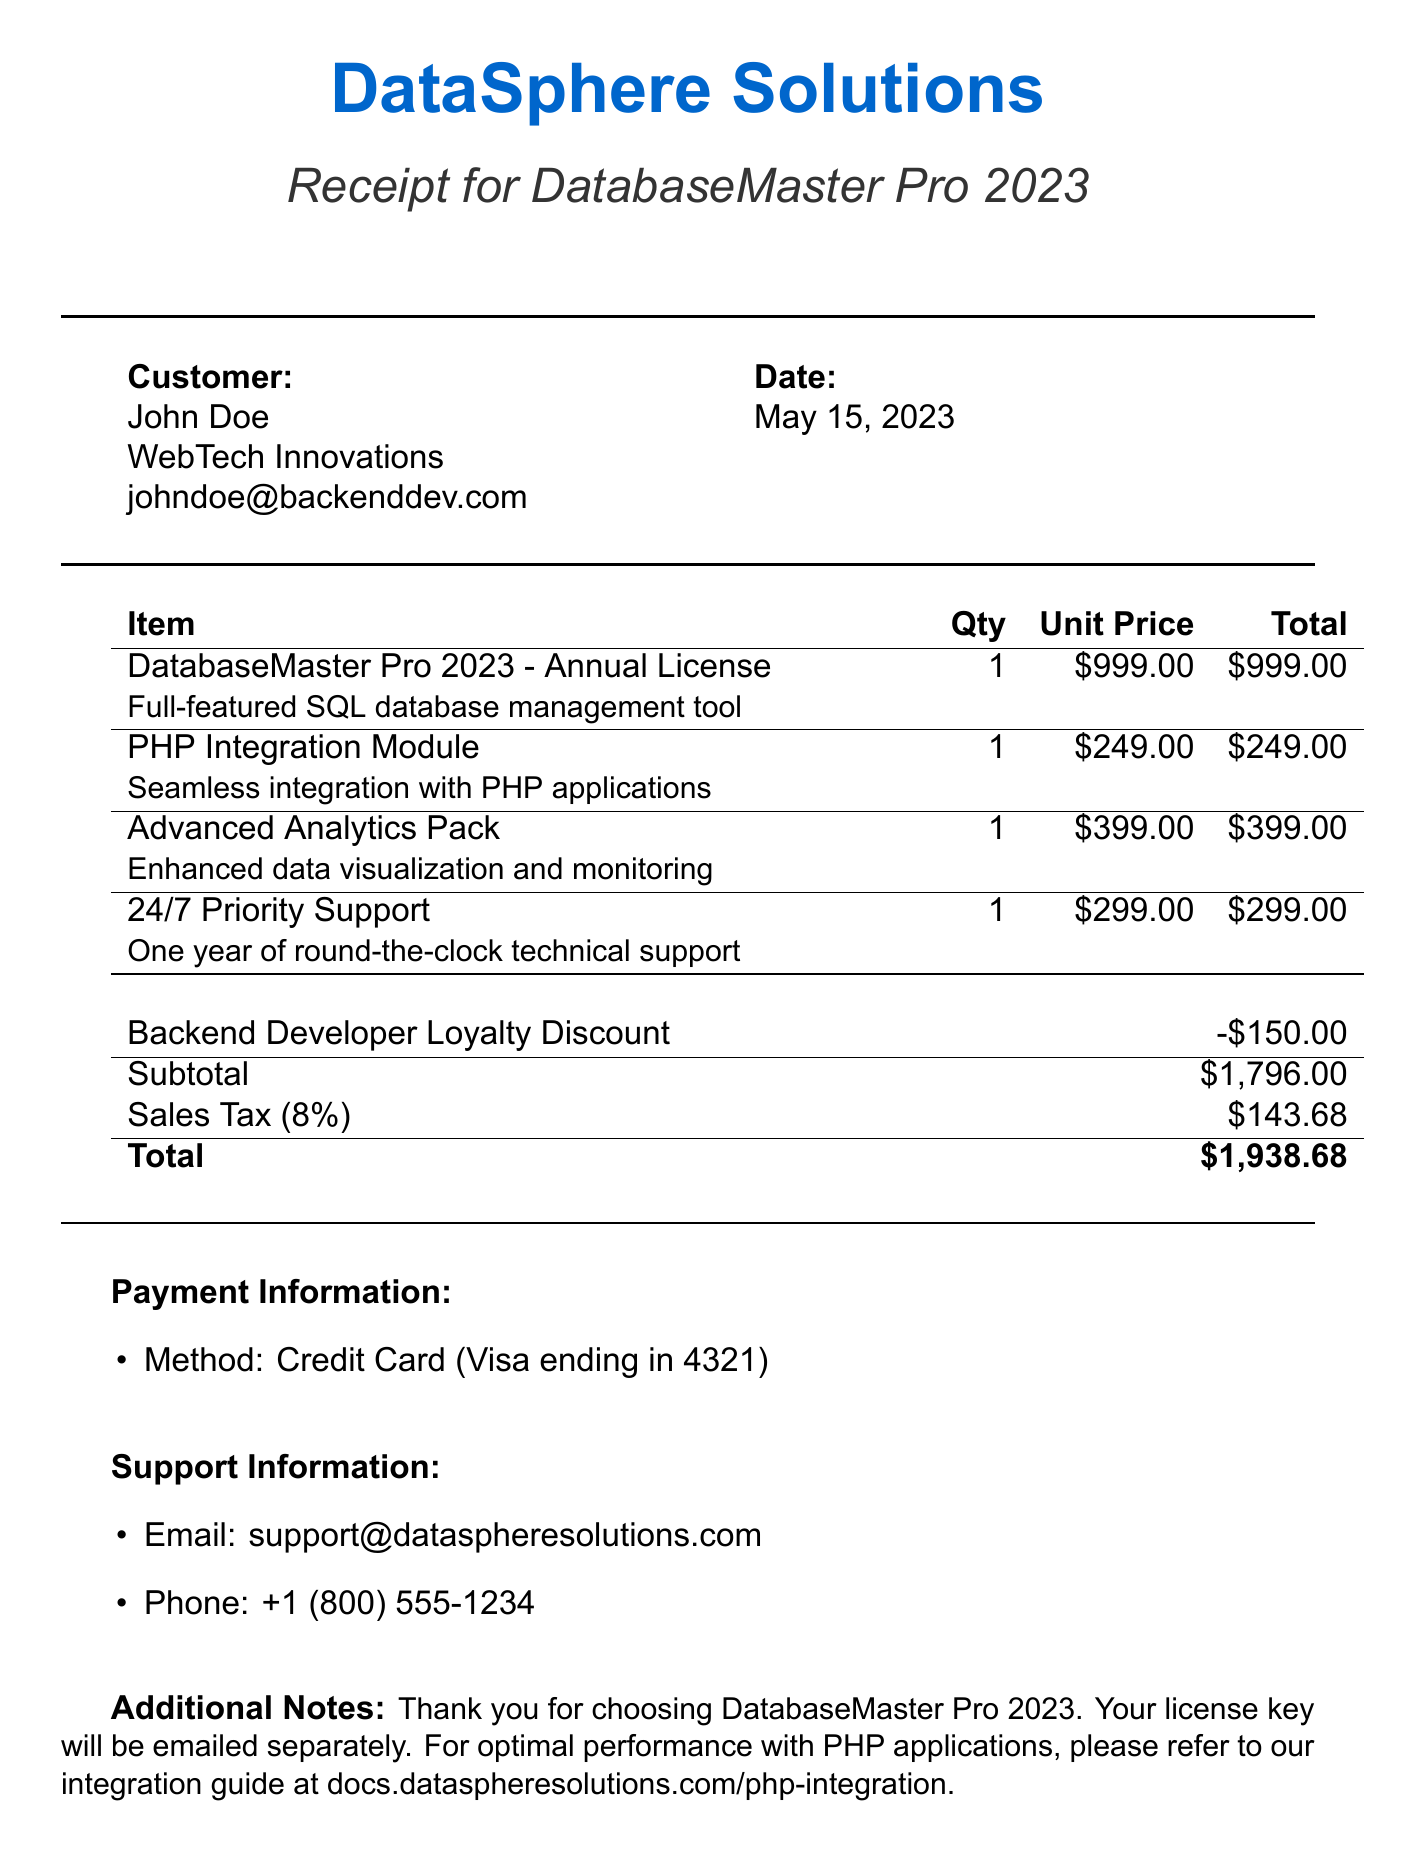what is the name of the product? The product name is listed under the purchase details.
Answer: DatabaseMaster Pro 2023 who is the customer? The customer's name is documented in the customer information section.
Answer: John Doe what is the purchase date? The date of purchase is specified in the document.
Answer: May 15, 2023 how much is the total for the purchase? The total amount is calculated after applying discounts and adding taxes.
Answer: $1,938.68 what is the unit price of the PHP Integration Module? The unit price of each item can be found in the itemized list.
Answer: $249.00 what type of payment was used? The payment method is detailed in the payment information section.
Answer: Credit Card how much was the Backend Developer Loyalty Discount? The amount of the discount is shown in the discounts section.
Answer: $150.00 how many items are included in the purchase? The number of items can be counted from the itemized list.
Answer: 4 what is the sales tax rate? The tax rate is specified in the taxes section.
Answer: 8% 